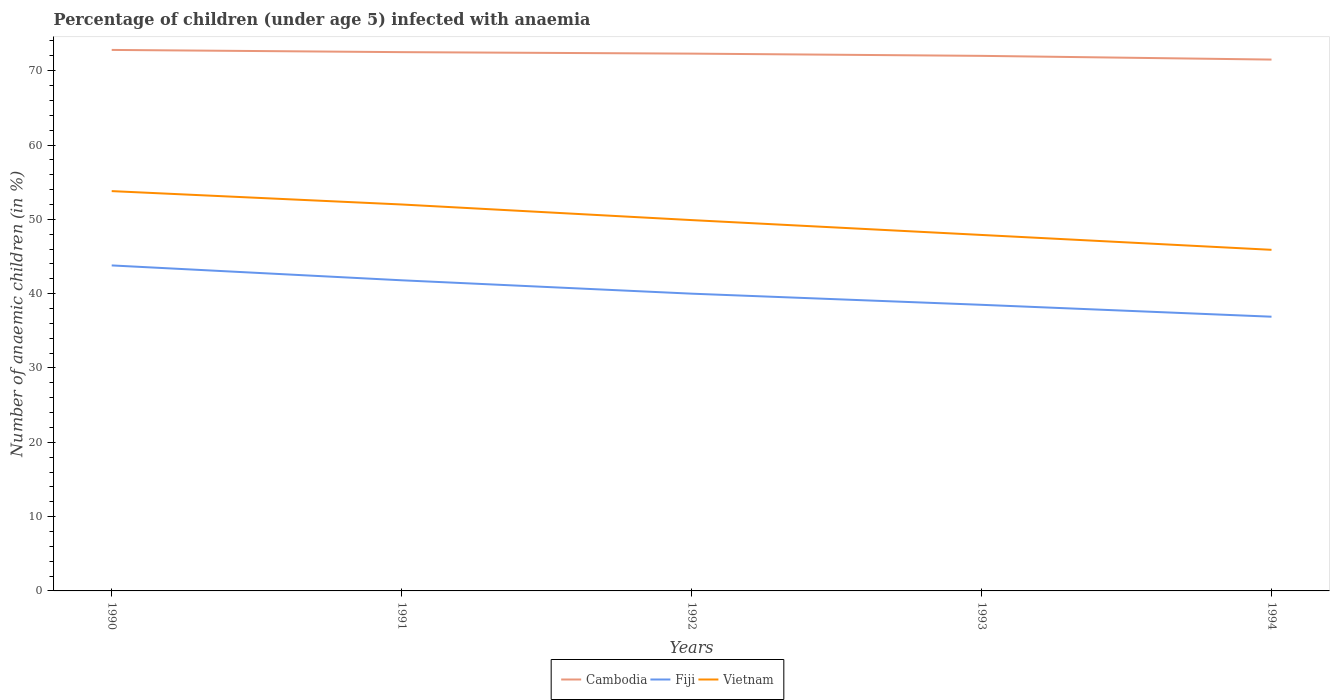How many different coloured lines are there?
Keep it short and to the point. 3. Across all years, what is the maximum percentage of children infected with anaemia in in Cambodia?
Ensure brevity in your answer.  71.5. In which year was the percentage of children infected with anaemia in in Cambodia maximum?
Keep it short and to the point. 1994. What is the total percentage of children infected with anaemia in in Vietnam in the graph?
Keep it short and to the point. 3.9. What is the difference between the highest and the second highest percentage of children infected with anaemia in in Fiji?
Ensure brevity in your answer.  6.9. What is the difference between the highest and the lowest percentage of children infected with anaemia in in Vietnam?
Give a very brief answer. 2. Is the percentage of children infected with anaemia in in Fiji strictly greater than the percentage of children infected with anaemia in in Cambodia over the years?
Give a very brief answer. Yes. How many lines are there?
Ensure brevity in your answer.  3. How many years are there in the graph?
Offer a terse response. 5. What is the difference between two consecutive major ticks on the Y-axis?
Ensure brevity in your answer.  10. Are the values on the major ticks of Y-axis written in scientific E-notation?
Provide a succinct answer. No. Where does the legend appear in the graph?
Make the answer very short. Bottom center. How many legend labels are there?
Your answer should be compact. 3. How are the legend labels stacked?
Offer a terse response. Horizontal. What is the title of the graph?
Keep it short and to the point. Percentage of children (under age 5) infected with anaemia. What is the label or title of the X-axis?
Your response must be concise. Years. What is the label or title of the Y-axis?
Provide a succinct answer. Number of anaemic children (in %). What is the Number of anaemic children (in %) of Cambodia in 1990?
Ensure brevity in your answer.  72.8. What is the Number of anaemic children (in %) of Fiji in 1990?
Keep it short and to the point. 43.8. What is the Number of anaemic children (in %) in Vietnam in 1990?
Keep it short and to the point. 53.8. What is the Number of anaemic children (in %) of Cambodia in 1991?
Ensure brevity in your answer.  72.5. What is the Number of anaemic children (in %) in Fiji in 1991?
Provide a short and direct response. 41.8. What is the Number of anaemic children (in %) of Vietnam in 1991?
Your response must be concise. 52. What is the Number of anaemic children (in %) of Cambodia in 1992?
Make the answer very short. 72.3. What is the Number of anaemic children (in %) in Fiji in 1992?
Your response must be concise. 40. What is the Number of anaemic children (in %) of Vietnam in 1992?
Ensure brevity in your answer.  49.9. What is the Number of anaemic children (in %) of Fiji in 1993?
Ensure brevity in your answer.  38.5. What is the Number of anaemic children (in %) in Vietnam in 1993?
Your answer should be very brief. 47.9. What is the Number of anaemic children (in %) of Cambodia in 1994?
Your response must be concise. 71.5. What is the Number of anaemic children (in %) of Fiji in 1994?
Your response must be concise. 36.9. What is the Number of anaemic children (in %) in Vietnam in 1994?
Ensure brevity in your answer.  45.9. Across all years, what is the maximum Number of anaemic children (in %) in Cambodia?
Offer a terse response. 72.8. Across all years, what is the maximum Number of anaemic children (in %) in Fiji?
Provide a short and direct response. 43.8. Across all years, what is the maximum Number of anaemic children (in %) of Vietnam?
Make the answer very short. 53.8. Across all years, what is the minimum Number of anaemic children (in %) of Cambodia?
Make the answer very short. 71.5. Across all years, what is the minimum Number of anaemic children (in %) of Fiji?
Offer a terse response. 36.9. Across all years, what is the minimum Number of anaemic children (in %) of Vietnam?
Provide a short and direct response. 45.9. What is the total Number of anaemic children (in %) in Cambodia in the graph?
Make the answer very short. 361.1. What is the total Number of anaemic children (in %) of Fiji in the graph?
Offer a terse response. 201. What is the total Number of anaemic children (in %) in Vietnam in the graph?
Ensure brevity in your answer.  249.5. What is the difference between the Number of anaemic children (in %) in Cambodia in 1990 and that in 1991?
Your response must be concise. 0.3. What is the difference between the Number of anaemic children (in %) of Vietnam in 1990 and that in 1991?
Offer a terse response. 1.8. What is the difference between the Number of anaemic children (in %) of Cambodia in 1990 and that in 1992?
Give a very brief answer. 0.5. What is the difference between the Number of anaemic children (in %) of Fiji in 1990 and that in 1992?
Provide a short and direct response. 3.8. What is the difference between the Number of anaemic children (in %) of Vietnam in 1990 and that in 1992?
Make the answer very short. 3.9. What is the difference between the Number of anaemic children (in %) in Vietnam in 1990 and that in 1993?
Keep it short and to the point. 5.9. What is the difference between the Number of anaemic children (in %) in Fiji in 1990 and that in 1994?
Offer a very short reply. 6.9. What is the difference between the Number of anaemic children (in %) in Vietnam in 1990 and that in 1994?
Offer a terse response. 7.9. What is the difference between the Number of anaemic children (in %) in Cambodia in 1991 and that in 1992?
Provide a short and direct response. 0.2. What is the difference between the Number of anaemic children (in %) of Vietnam in 1991 and that in 1992?
Ensure brevity in your answer.  2.1. What is the difference between the Number of anaemic children (in %) in Fiji in 1991 and that in 1993?
Ensure brevity in your answer.  3.3. What is the difference between the Number of anaemic children (in %) in Vietnam in 1991 and that in 1993?
Offer a very short reply. 4.1. What is the difference between the Number of anaemic children (in %) in Cambodia in 1991 and that in 1994?
Provide a short and direct response. 1. What is the difference between the Number of anaemic children (in %) of Fiji in 1991 and that in 1994?
Your answer should be very brief. 4.9. What is the difference between the Number of anaemic children (in %) of Cambodia in 1992 and that in 1993?
Your answer should be compact. 0.3. What is the difference between the Number of anaemic children (in %) of Vietnam in 1992 and that in 1993?
Offer a very short reply. 2. What is the difference between the Number of anaemic children (in %) in Cambodia in 1992 and that in 1994?
Keep it short and to the point. 0.8. What is the difference between the Number of anaemic children (in %) of Fiji in 1992 and that in 1994?
Offer a terse response. 3.1. What is the difference between the Number of anaemic children (in %) in Vietnam in 1992 and that in 1994?
Your response must be concise. 4. What is the difference between the Number of anaemic children (in %) of Cambodia in 1990 and the Number of anaemic children (in %) of Vietnam in 1991?
Make the answer very short. 20.8. What is the difference between the Number of anaemic children (in %) in Cambodia in 1990 and the Number of anaemic children (in %) in Fiji in 1992?
Your answer should be compact. 32.8. What is the difference between the Number of anaemic children (in %) in Cambodia in 1990 and the Number of anaemic children (in %) in Vietnam in 1992?
Offer a terse response. 22.9. What is the difference between the Number of anaemic children (in %) in Fiji in 1990 and the Number of anaemic children (in %) in Vietnam in 1992?
Keep it short and to the point. -6.1. What is the difference between the Number of anaemic children (in %) of Cambodia in 1990 and the Number of anaemic children (in %) of Fiji in 1993?
Offer a very short reply. 34.3. What is the difference between the Number of anaemic children (in %) of Cambodia in 1990 and the Number of anaemic children (in %) of Vietnam in 1993?
Give a very brief answer. 24.9. What is the difference between the Number of anaemic children (in %) in Cambodia in 1990 and the Number of anaemic children (in %) in Fiji in 1994?
Your answer should be compact. 35.9. What is the difference between the Number of anaemic children (in %) of Cambodia in 1990 and the Number of anaemic children (in %) of Vietnam in 1994?
Provide a short and direct response. 26.9. What is the difference between the Number of anaemic children (in %) of Fiji in 1990 and the Number of anaemic children (in %) of Vietnam in 1994?
Offer a terse response. -2.1. What is the difference between the Number of anaemic children (in %) in Cambodia in 1991 and the Number of anaemic children (in %) in Fiji in 1992?
Offer a very short reply. 32.5. What is the difference between the Number of anaemic children (in %) in Cambodia in 1991 and the Number of anaemic children (in %) in Vietnam in 1992?
Make the answer very short. 22.6. What is the difference between the Number of anaemic children (in %) of Fiji in 1991 and the Number of anaemic children (in %) of Vietnam in 1992?
Make the answer very short. -8.1. What is the difference between the Number of anaemic children (in %) in Cambodia in 1991 and the Number of anaemic children (in %) in Fiji in 1993?
Offer a terse response. 34. What is the difference between the Number of anaemic children (in %) of Cambodia in 1991 and the Number of anaemic children (in %) of Vietnam in 1993?
Make the answer very short. 24.6. What is the difference between the Number of anaemic children (in %) in Cambodia in 1991 and the Number of anaemic children (in %) in Fiji in 1994?
Your response must be concise. 35.6. What is the difference between the Number of anaemic children (in %) of Cambodia in 1991 and the Number of anaemic children (in %) of Vietnam in 1994?
Keep it short and to the point. 26.6. What is the difference between the Number of anaemic children (in %) of Cambodia in 1992 and the Number of anaemic children (in %) of Fiji in 1993?
Offer a very short reply. 33.8. What is the difference between the Number of anaemic children (in %) in Cambodia in 1992 and the Number of anaemic children (in %) in Vietnam in 1993?
Provide a succinct answer. 24.4. What is the difference between the Number of anaemic children (in %) in Cambodia in 1992 and the Number of anaemic children (in %) in Fiji in 1994?
Your answer should be very brief. 35.4. What is the difference between the Number of anaemic children (in %) of Cambodia in 1992 and the Number of anaemic children (in %) of Vietnam in 1994?
Keep it short and to the point. 26.4. What is the difference between the Number of anaemic children (in %) of Cambodia in 1993 and the Number of anaemic children (in %) of Fiji in 1994?
Offer a terse response. 35.1. What is the difference between the Number of anaemic children (in %) in Cambodia in 1993 and the Number of anaemic children (in %) in Vietnam in 1994?
Offer a very short reply. 26.1. What is the difference between the Number of anaemic children (in %) in Fiji in 1993 and the Number of anaemic children (in %) in Vietnam in 1994?
Offer a very short reply. -7.4. What is the average Number of anaemic children (in %) in Cambodia per year?
Provide a succinct answer. 72.22. What is the average Number of anaemic children (in %) of Fiji per year?
Provide a short and direct response. 40.2. What is the average Number of anaemic children (in %) in Vietnam per year?
Provide a succinct answer. 49.9. In the year 1990, what is the difference between the Number of anaemic children (in %) in Cambodia and Number of anaemic children (in %) in Vietnam?
Ensure brevity in your answer.  19. In the year 1991, what is the difference between the Number of anaemic children (in %) in Cambodia and Number of anaemic children (in %) in Fiji?
Offer a very short reply. 30.7. In the year 1992, what is the difference between the Number of anaemic children (in %) of Cambodia and Number of anaemic children (in %) of Fiji?
Keep it short and to the point. 32.3. In the year 1992, what is the difference between the Number of anaemic children (in %) in Cambodia and Number of anaemic children (in %) in Vietnam?
Give a very brief answer. 22.4. In the year 1993, what is the difference between the Number of anaemic children (in %) in Cambodia and Number of anaemic children (in %) in Fiji?
Provide a short and direct response. 33.5. In the year 1993, what is the difference between the Number of anaemic children (in %) of Cambodia and Number of anaemic children (in %) of Vietnam?
Your answer should be very brief. 24.1. In the year 1994, what is the difference between the Number of anaemic children (in %) in Cambodia and Number of anaemic children (in %) in Fiji?
Ensure brevity in your answer.  34.6. In the year 1994, what is the difference between the Number of anaemic children (in %) of Cambodia and Number of anaemic children (in %) of Vietnam?
Provide a short and direct response. 25.6. What is the ratio of the Number of anaemic children (in %) in Fiji in 1990 to that in 1991?
Your answer should be compact. 1.05. What is the ratio of the Number of anaemic children (in %) in Vietnam in 1990 to that in 1991?
Keep it short and to the point. 1.03. What is the ratio of the Number of anaemic children (in %) in Fiji in 1990 to that in 1992?
Give a very brief answer. 1.09. What is the ratio of the Number of anaemic children (in %) in Vietnam in 1990 to that in 1992?
Offer a very short reply. 1.08. What is the ratio of the Number of anaemic children (in %) in Cambodia in 1990 to that in 1993?
Ensure brevity in your answer.  1.01. What is the ratio of the Number of anaemic children (in %) of Fiji in 1990 to that in 1993?
Give a very brief answer. 1.14. What is the ratio of the Number of anaemic children (in %) of Vietnam in 1990 to that in 1993?
Your answer should be compact. 1.12. What is the ratio of the Number of anaemic children (in %) in Cambodia in 1990 to that in 1994?
Offer a terse response. 1.02. What is the ratio of the Number of anaemic children (in %) in Fiji in 1990 to that in 1994?
Your response must be concise. 1.19. What is the ratio of the Number of anaemic children (in %) in Vietnam in 1990 to that in 1994?
Offer a terse response. 1.17. What is the ratio of the Number of anaemic children (in %) in Cambodia in 1991 to that in 1992?
Give a very brief answer. 1. What is the ratio of the Number of anaemic children (in %) of Fiji in 1991 to that in 1992?
Offer a very short reply. 1.04. What is the ratio of the Number of anaemic children (in %) in Vietnam in 1991 to that in 1992?
Make the answer very short. 1.04. What is the ratio of the Number of anaemic children (in %) of Cambodia in 1991 to that in 1993?
Your answer should be compact. 1.01. What is the ratio of the Number of anaemic children (in %) of Fiji in 1991 to that in 1993?
Keep it short and to the point. 1.09. What is the ratio of the Number of anaemic children (in %) in Vietnam in 1991 to that in 1993?
Your answer should be very brief. 1.09. What is the ratio of the Number of anaemic children (in %) of Cambodia in 1991 to that in 1994?
Your response must be concise. 1.01. What is the ratio of the Number of anaemic children (in %) of Fiji in 1991 to that in 1994?
Your response must be concise. 1.13. What is the ratio of the Number of anaemic children (in %) of Vietnam in 1991 to that in 1994?
Your answer should be compact. 1.13. What is the ratio of the Number of anaemic children (in %) in Fiji in 1992 to that in 1993?
Your response must be concise. 1.04. What is the ratio of the Number of anaemic children (in %) in Vietnam in 1992 to that in 1993?
Offer a terse response. 1.04. What is the ratio of the Number of anaemic children (in %) of Cambodia in 1992 to that in 1994?
Your answer should be compact. 1.01. What is the ratio of the Number of anaemic children (in %) of Fiji in 1992 to that in 1994?
Offer a terse response. 1.08. What is the ratio of the Number of anaemic children (in %) in Vietnam in 1992 to that in 1994?
Keep it short and to the point. 1.09. What is the ratio of the Number of anaemic children (in %) in Fiji in 1993 to that in 1994?
Give a very brief answer. 1.04. What is the ratio of the Number of anaemic children (in %) in Vietnam in 1993 to that in 1994?
Provide a short and direct response. 1.04. What is the difference between the highest and the second highest Number of anaemic children (in %) of Cambodia?
Ensure brevity in your answer.  0.3. What is the difference between the highest and the second highest Number of anaemic children (in %) in Fiji?
Provide a succinct answer. 2. What is the difference between the highest and the lowest Number of anaemic children (in %) in Fiji?
Your answer should be compact. 6.9. What is the difference between the highest and the lowest Number of anaemic children (in %) of Vietnam?
Make the answer very short. 7.9. 